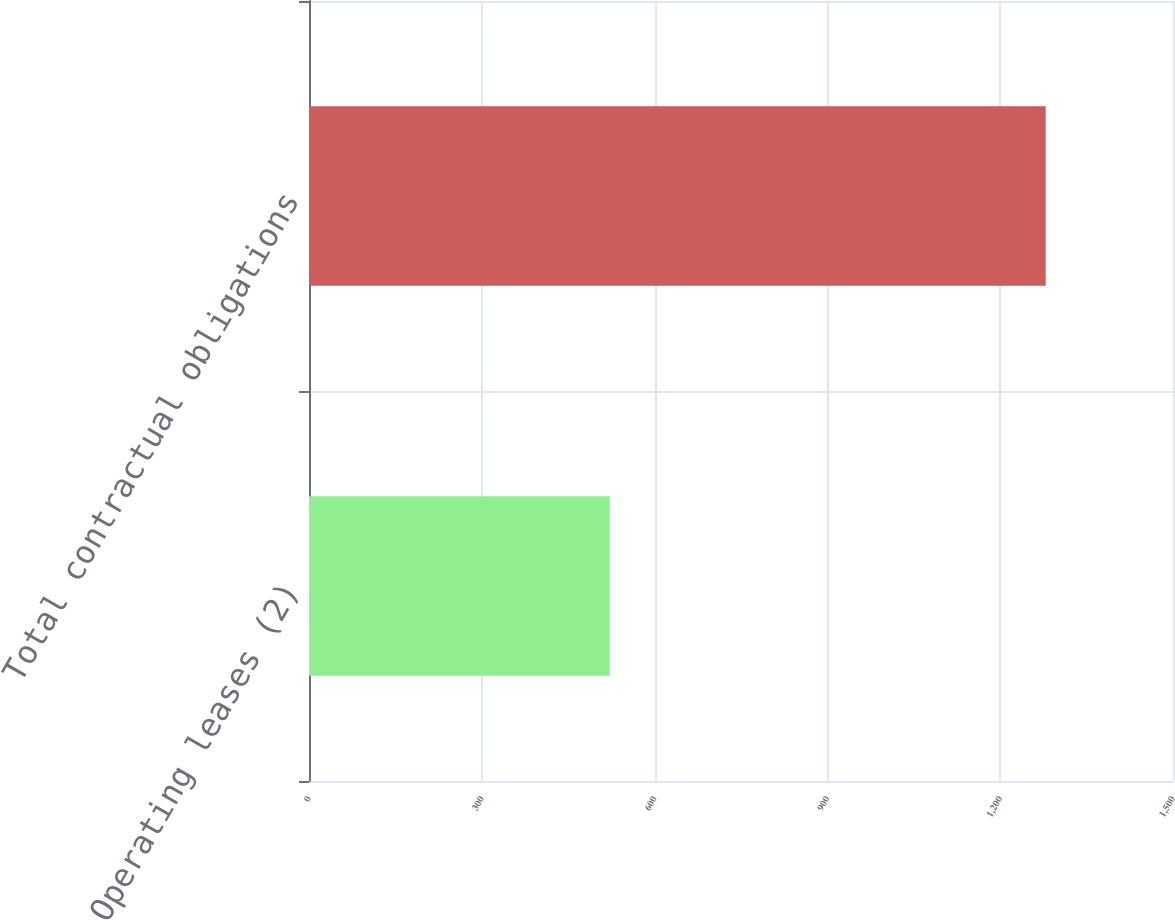Convert chart. <chart><loc_0><loc_0><loc_500><loc_500><bar_chart><fcel>Operating leases (2)<fcel>Total contractual obligations<nl><fcel>522<fcel>1279<nl></chart> 